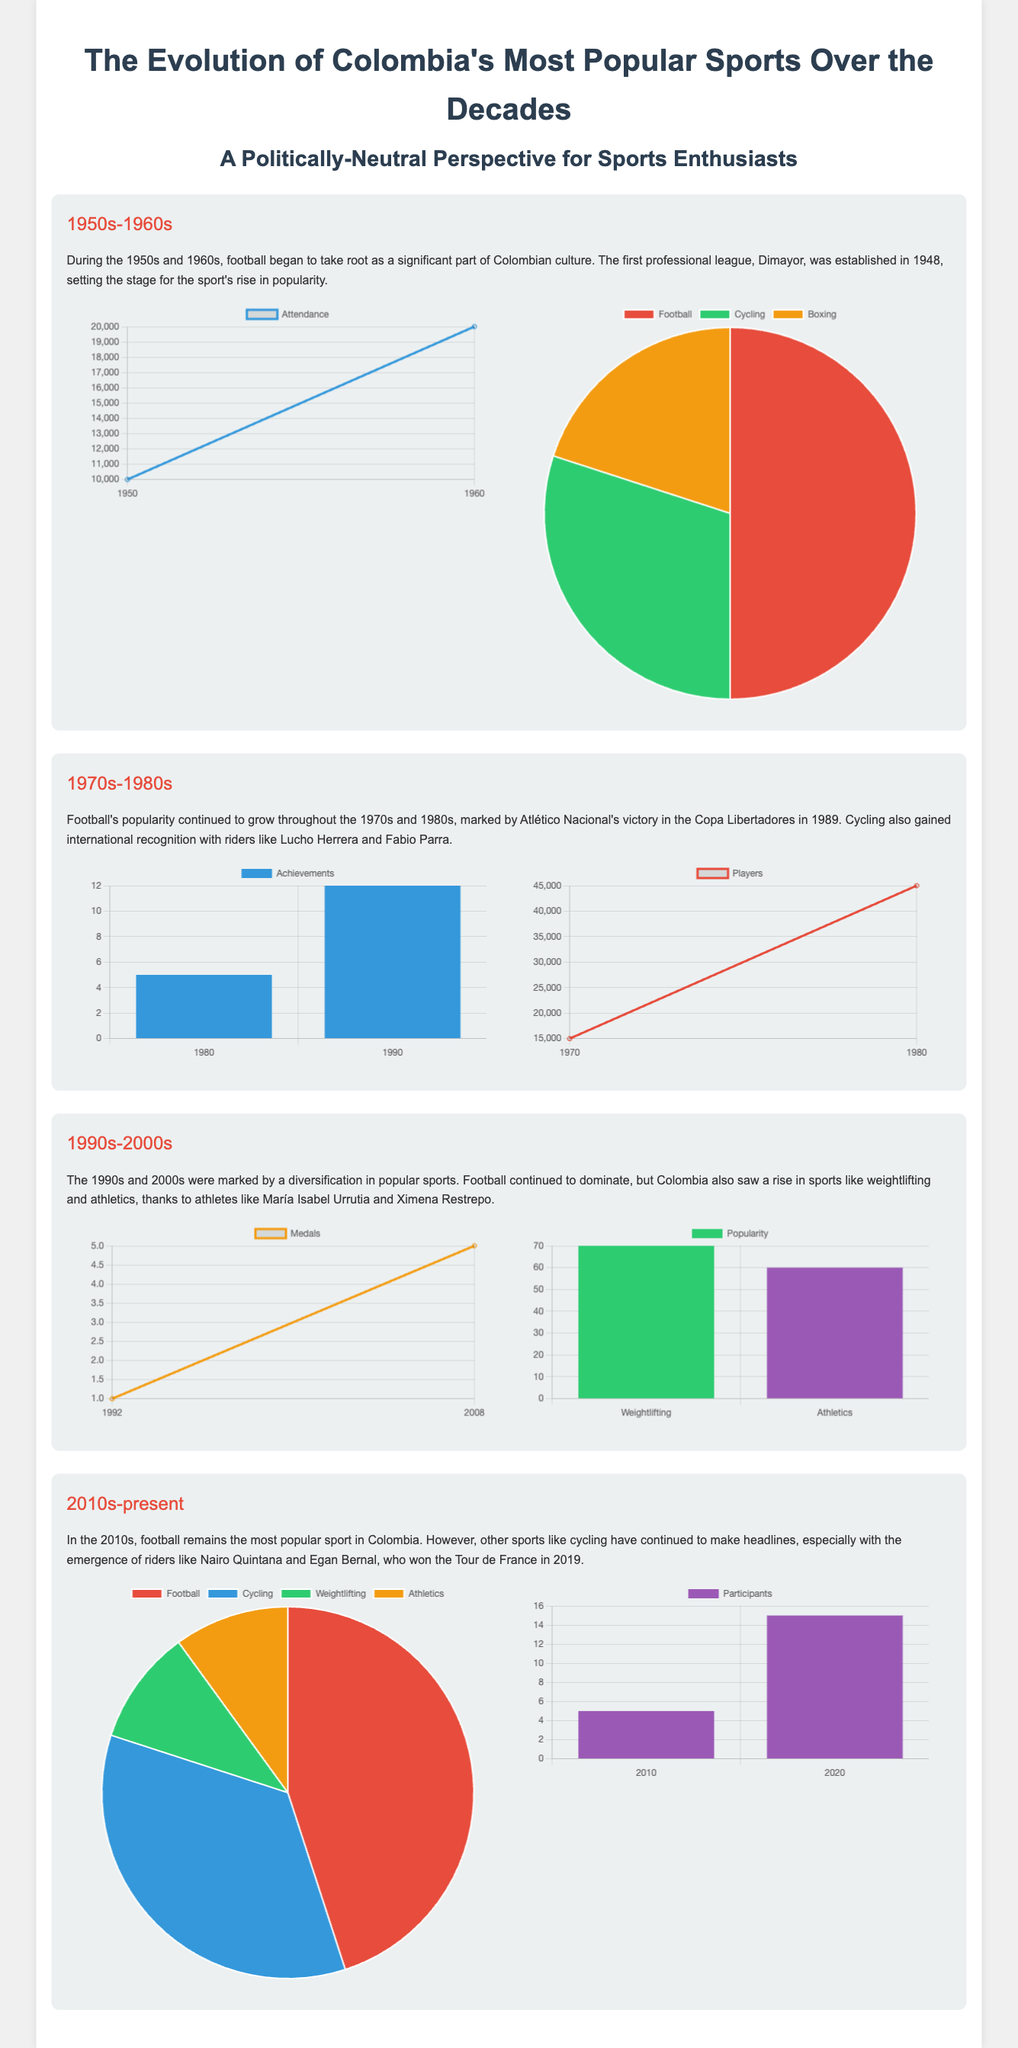What sport began to take root in Colombia in the 1950s? The document mentions that football began to take root in Colombia's culture during the 1950s and 1960s.
Answer: Football What year did Atlético Nacional win the Copa Libertadores? The document states that Atlético Nacional won the Copa Libertadores in 1989, highlighting the growth of football.
Answer: 1989 How many medals did Colombia win in the Olympic Games in 2008? According to the document, Colombia won 5 medals in the Olympic Games in 2008.
Answer: 5 What was the popularity percentage of football in 2020? The chart indicates that football had a popularity percentage of 45% in 2020.
Answer: 45% What was the number of registered football players in 1980? The document provides the number of registered football players as 45,000 in 1980.
Answer: 45000 Which two sports gained popularity due to notable athletes in the 1990s and 2000s? The document identifies weightlifting and athletics as the sports that gained popularity due to notable athletes.
Answer: Weightlifting and Athletics How did the attendance at football matches change from 1950 to 1960? The document highlights the increase in attendance from 10,000 in 1950 to 20,000 in 1960.
Answer: Increased What sport had a pie chart representation in the 1960s showing 30% popularity? The pie chart in the document shows that cycling had a 30% popularity in the 1960s.
Answer: Cycling How many participants were there in the Tour de France in 2020? According to the document, there were 15 participants from Colombia in the Tour de France in 2020.
Answer: 15 